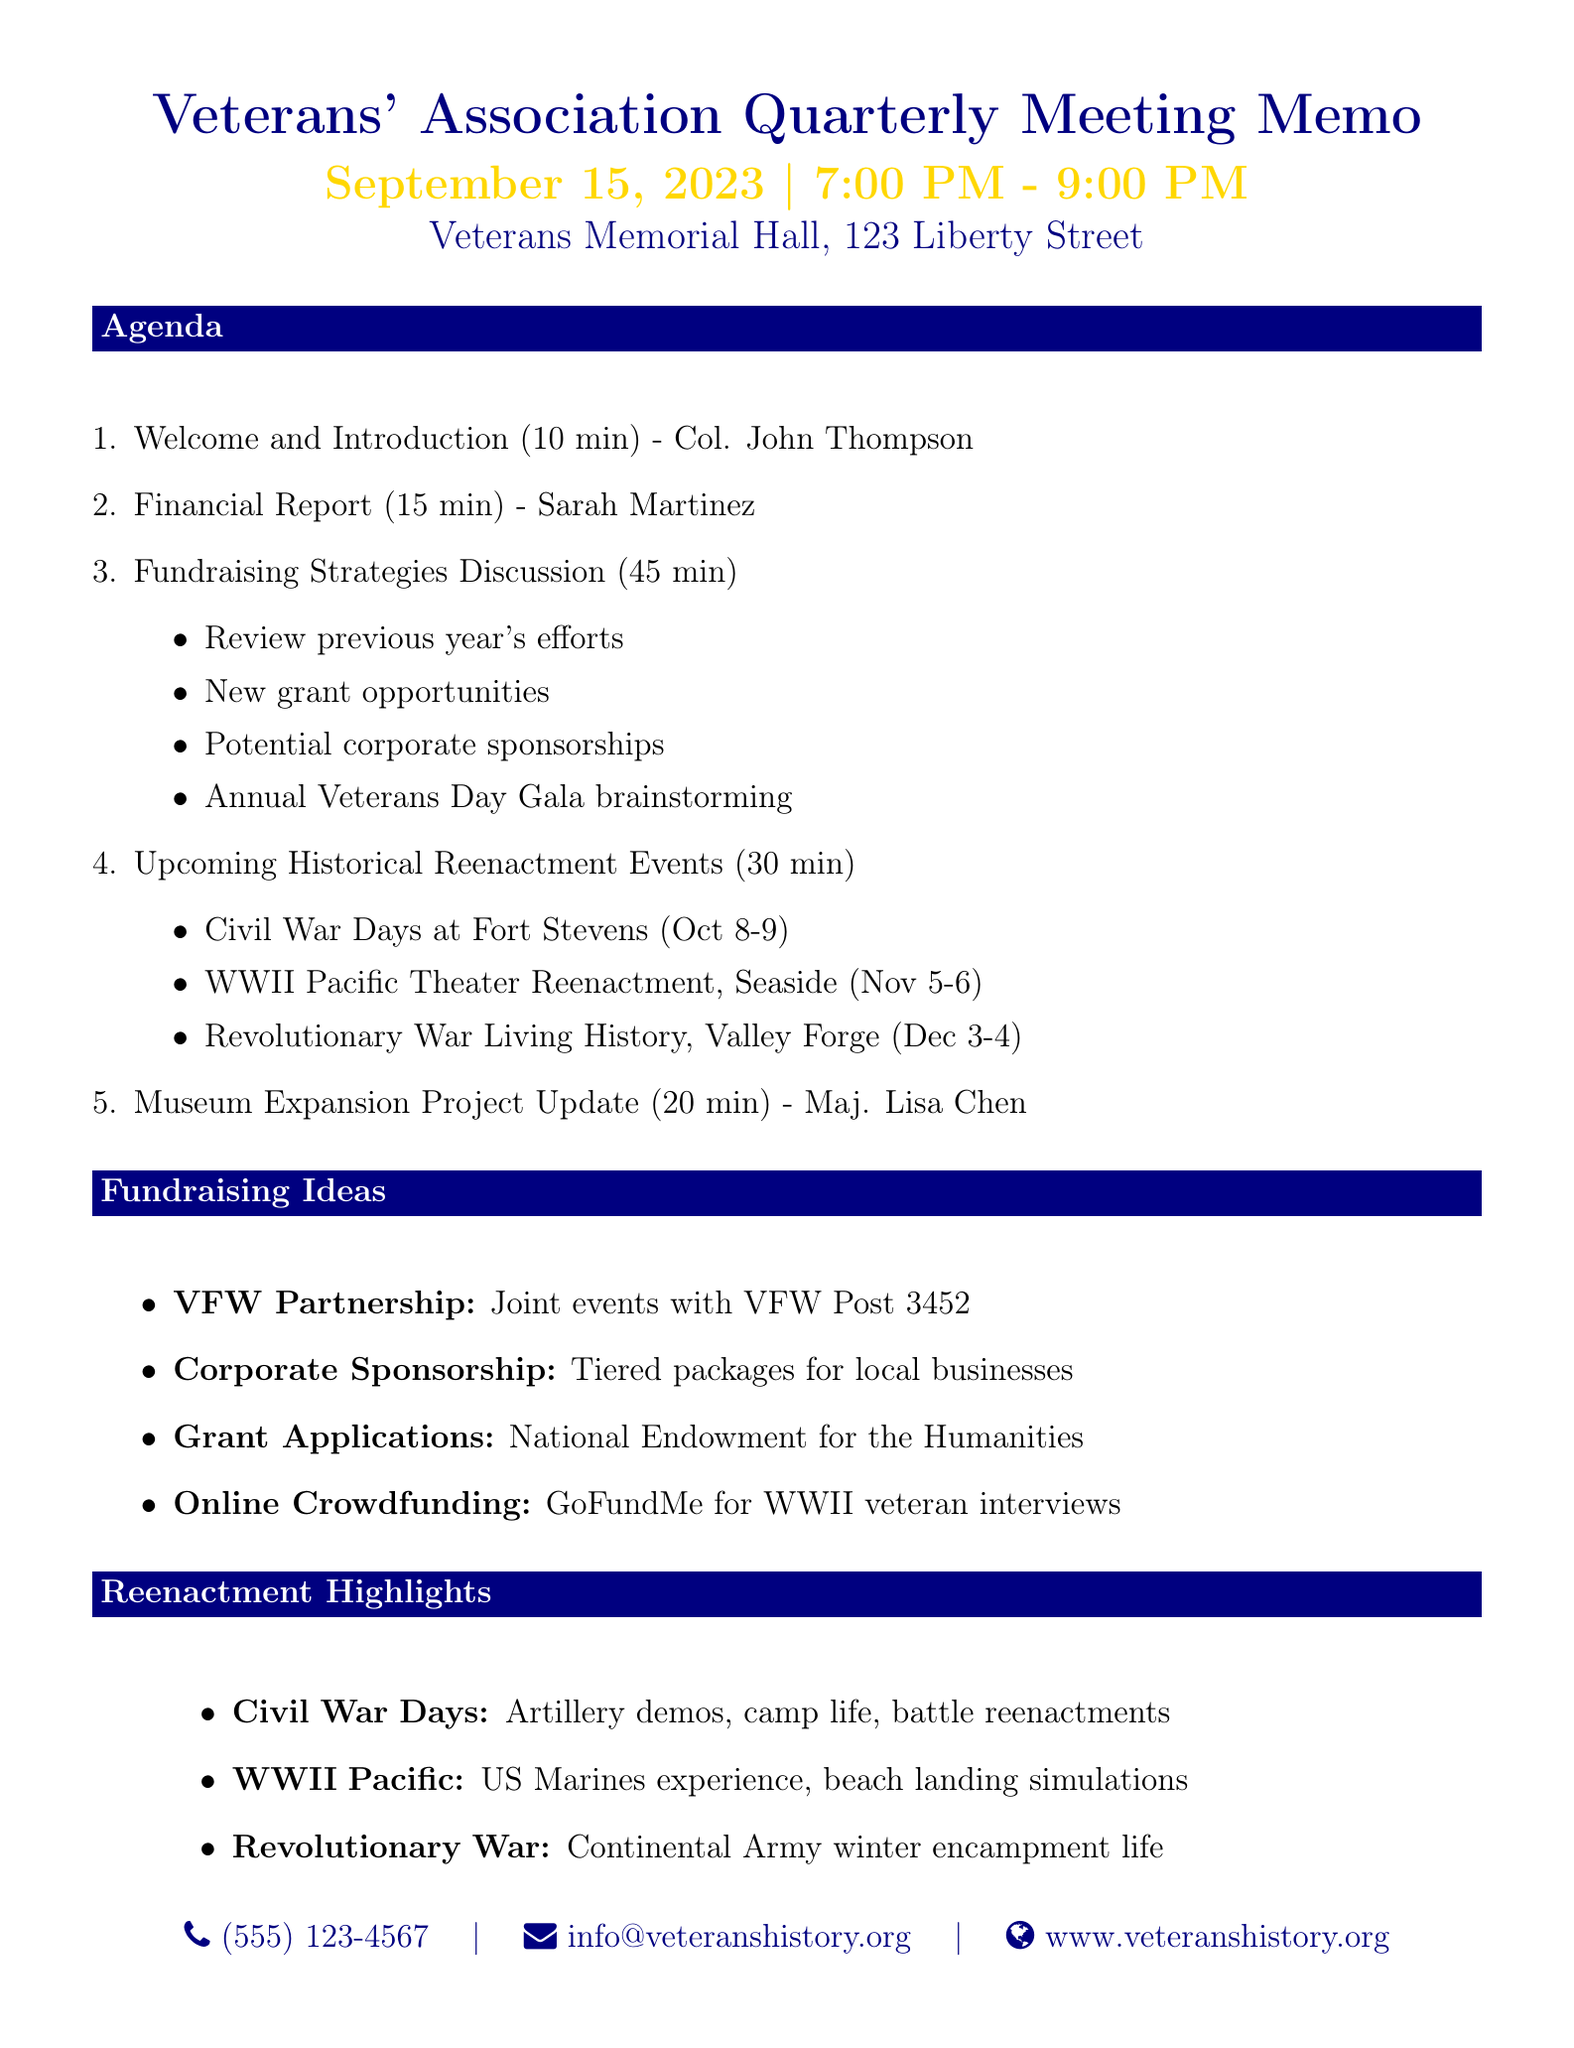What is the date of the meeting? The date of the meeting is explicitly stated in the document under meeting details.
Answer: September 15, 2023 Who will present the financial report? The financial report presentation is assigned to a specific individual mentioned in the agenda.
Answer: Sarah Martinez How long is the fundraising strategies discussion scheduled for? The duration for the fundraising strategies discussion can be found in the agenda items section.
Answer: 45 minutes What event is scheduled for October 8-9, 2023? The document lists specific upcoming reenactment events with their corresponding dates.
Answer: Civil War Days at Fort Stevens What is one of the fundraising ideas mentioned? Several fundraising ideas are listed in the document, and we can refer to this list for a specific example.
Answer: VFW Partnership How many historical reenactment events are listed? By counting the events mentioned in the document, we find the total number of events scheduled.
Answer: Three What is the location of the WWII Pacific Theater reenactment? Each event in the document is accompanied by its location, allowing for specific retrieval.
Answer: Seaside, Oregon Who is updating the museum expansion project? The document specifies the presenter for the museum expansion update in the agenda.
Answer: Major Lisa Chen What is the focus of the Revolutionary War event? The description of this event in the document provides insights into its content and focus.
Answer: Daily life of Continental Army soldiers 